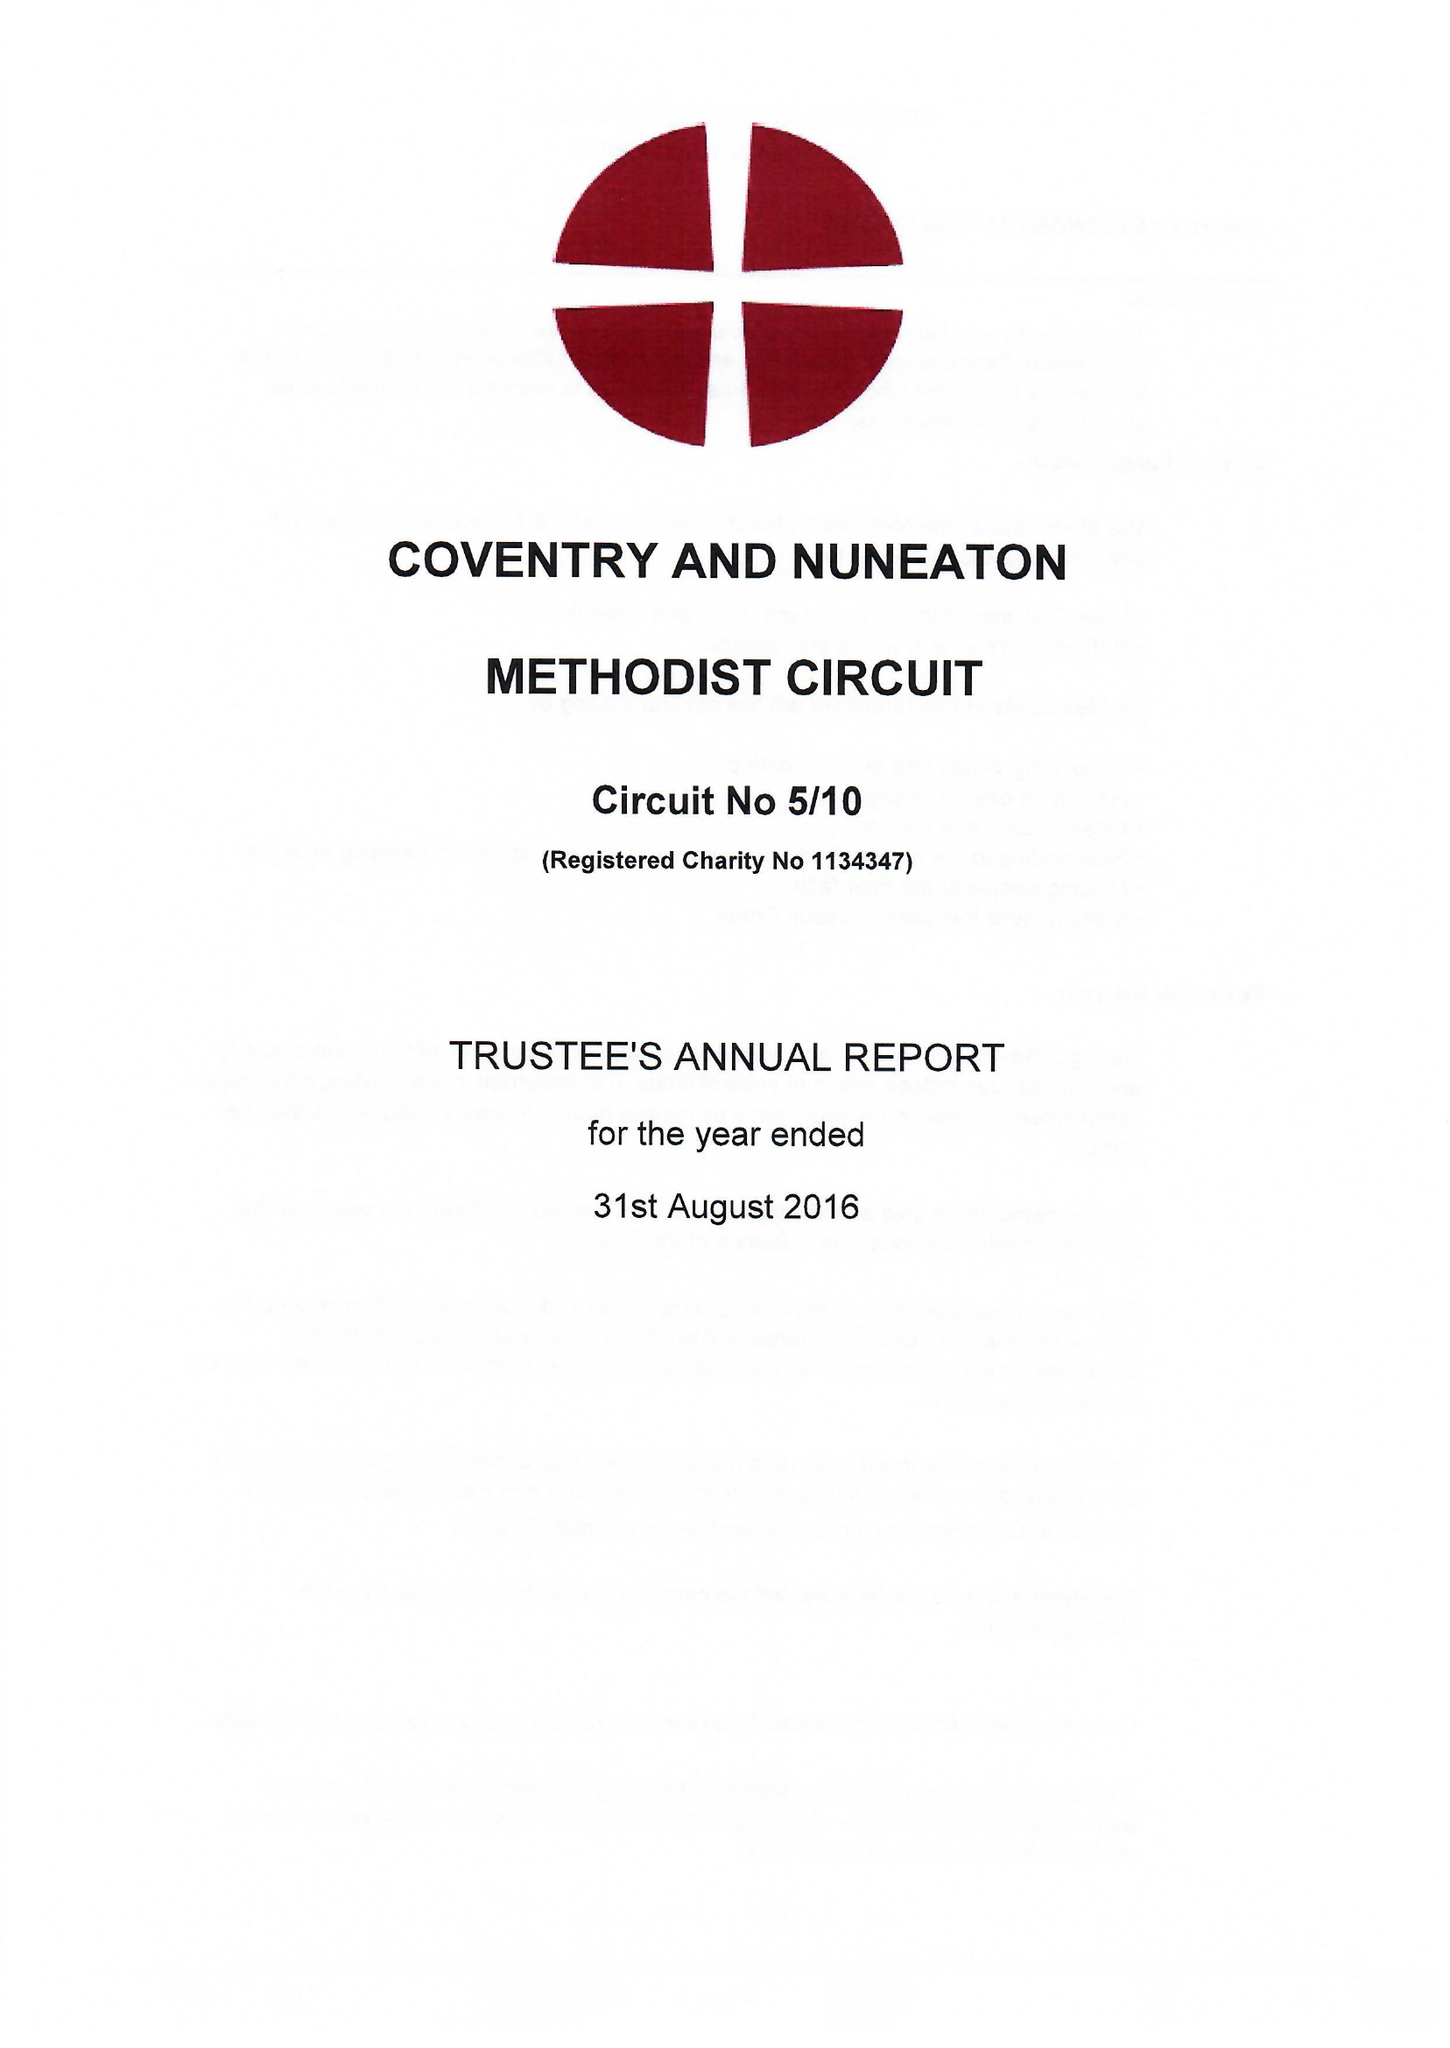What is the value for the spending_annually_in_british_pounds?
Answer the question using a single word or phrase. 475127.00 